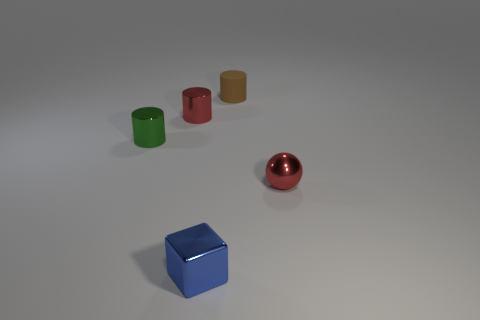Subtract all brown cylinders. How many cylinders are left? 2 Subtract all green cylinders. How many cylinders are left? 2 Subtract all spheres. How many objects are left? 4 Add 1 small shiny balls. How many objects exist? 6 Add 5 rubber things. How many rubber things exist? 6 Subtract 0 red blocks. How many objects are left? 5 Subtract 3 cylinders. How many cylinders are left? 0 Subtract all green cylinders. Subtract all purple cubes. How many cylinders are left? 2 Subtract all blue spheres. How many red cylinders are left? 1 Subtract all small purple matte cylinders. Subtract all red objects. How many objects are left? 3 